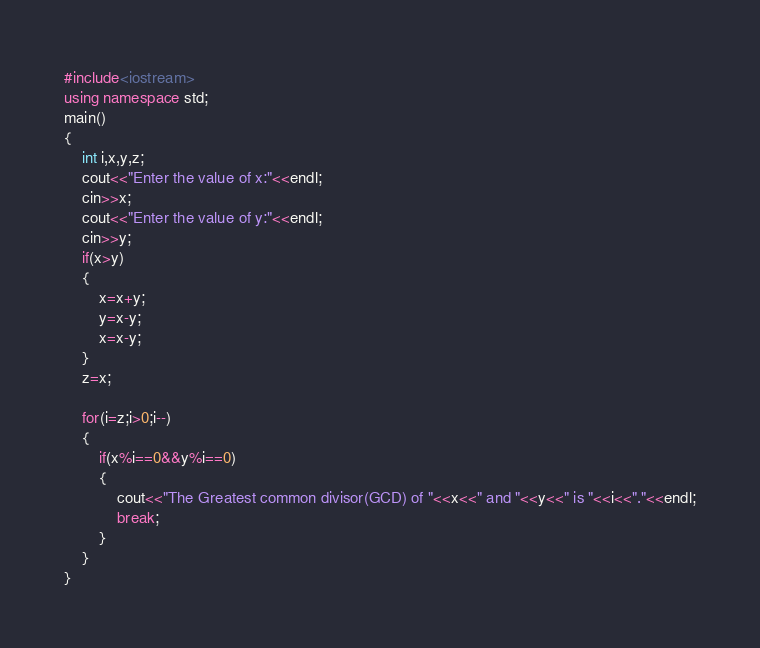Convert code to text. <code><loc_0><loc_0><loc_500><loc_500><_C++_>#include<iostream>
using namespace std;
main()
{
    int i,x,y,z;
    cout<<"Enter the value of x:"<<endl;
    cin>>x;
    cout<<"Enter the value of y:"<<endl;
    cin>>y;
    if(x>y)
    {
        x=x+y;
        y=x-y;
        x=x-y;
    }
    z=x;

    for(i=z;i>0;i--)
    {
        if(x%i==0&&y%i==0)
        {
            cout<<"The Greatest common divisor(GCD) of "<<x<<" and "<<y<<" is "<<i<<"."<<endl;
            break;
        }
    }
}
</code> 